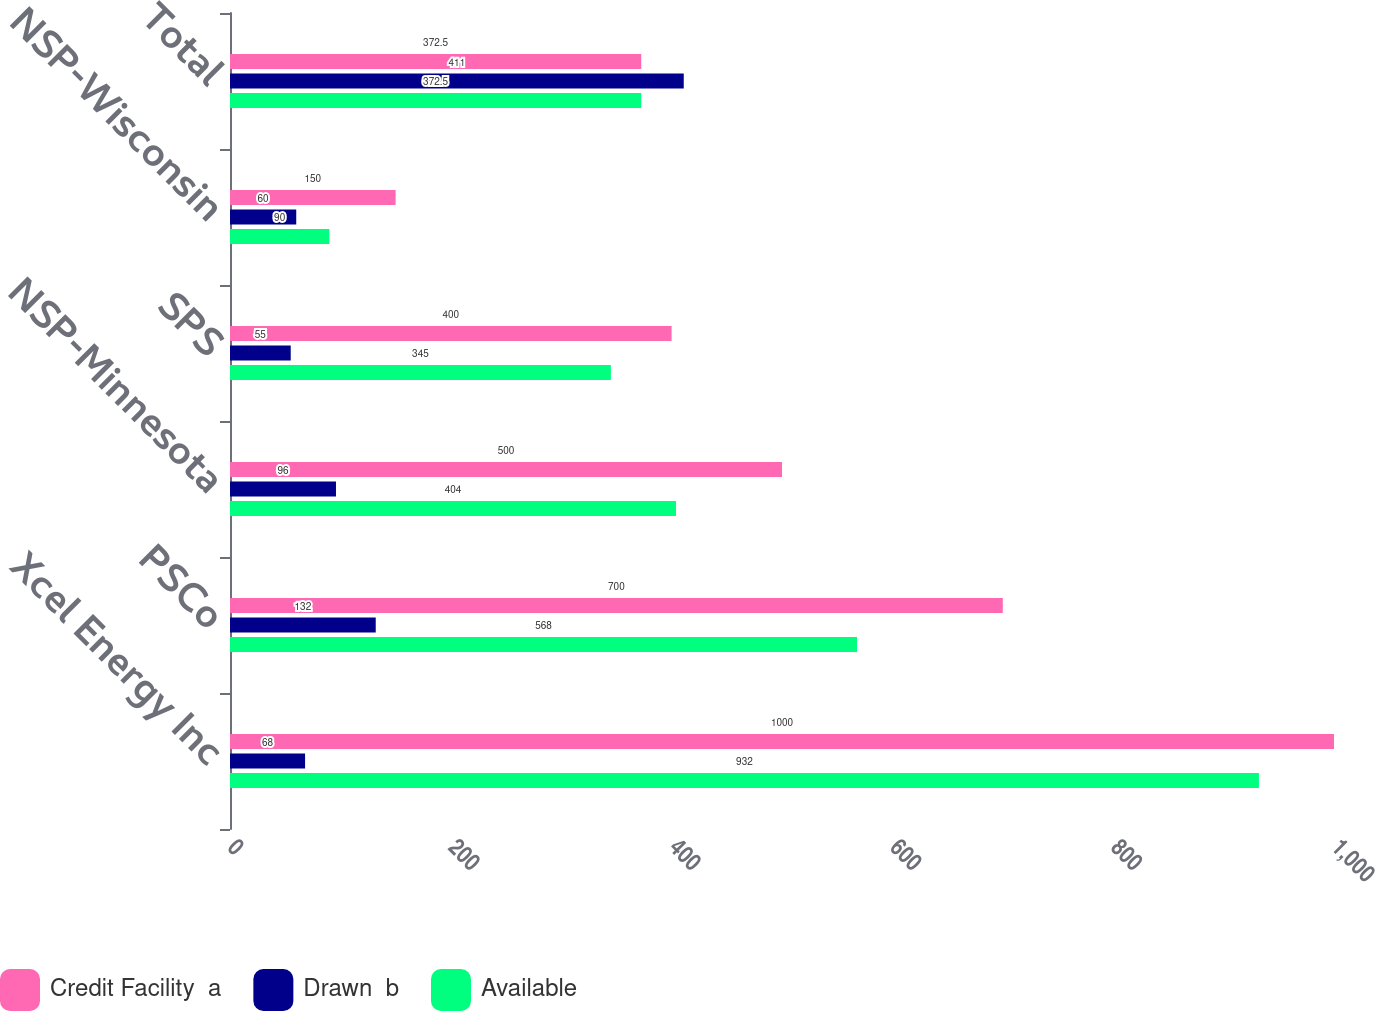Convert chart to OTSL. <chart><loc_0><loc_0><loc_500><loc_500><stacked_bar_chart><ecel><fcel>Xcel Energy Inc<fcel>PSCo<fcel>NSP-Minnesota<fcel>SPS<fcel>NSP-Wisconsin<fcel>Total<nl><fcel>Credit Facility  a<fcel>1000<fcel>700<fcel>500<fcel>400<fcel>150<fcel>372.5<nl><fcel>Drawn  b<fcel>68<fcel>132<fcel>96<fcel>55<fcel>60<fcel>411<nl><fcel>Available<fcel>932<fcel>568<fcel>404<fcel>345<fcel>90<fcel>372.5<nl></chart> 